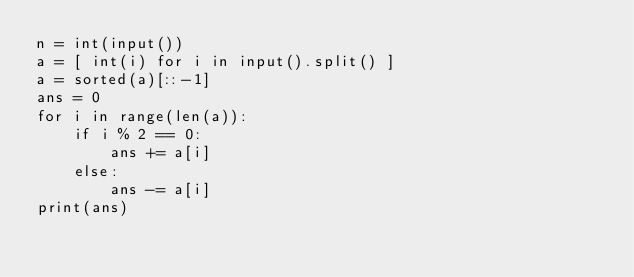Convert code to text. <code><loc_0><loc_0><loc_500><loc_500><_Python_>n = int(input())
a = [ int(i) for i in input().split() ]
a = sorted(a)[::-1]
ans = 0
for i in range(len(a)):
    if i % 2 == 0:
        ans += a[i]
    else:
        ans -= a[i]
print(ans)
</code> 